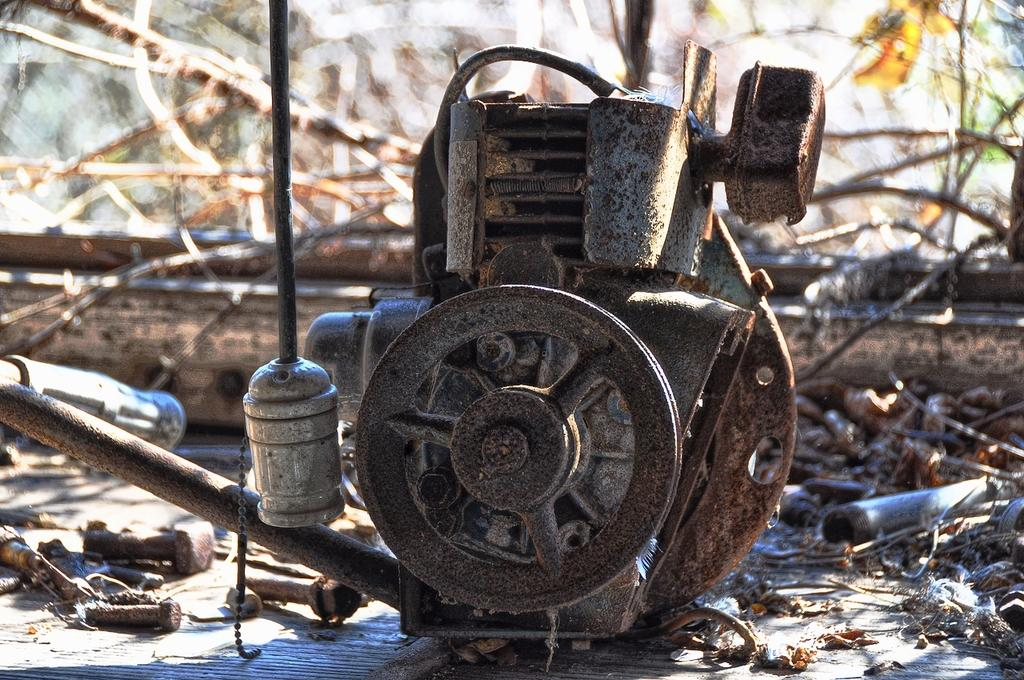What is the main object on the ground in the image? There is a machine on the ground in the image. What can be seen in the background of the image? There are wooden sticks visible in the background of the image. How many passengers are sitting on top of the machine in the image? There are no passengers sitting on top of the machine in the image, as there is no indication of any people or passengers present. 